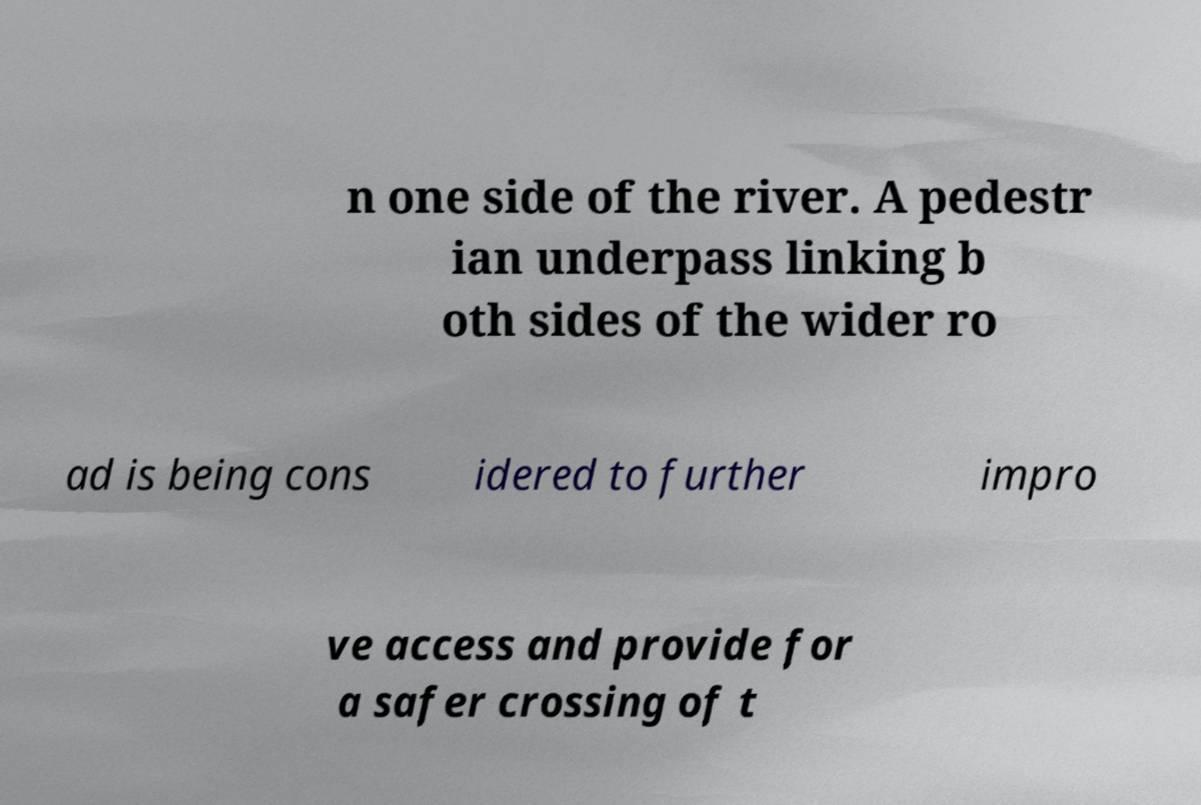I need the written content from this picture converted into text. Can you do that? n one side of the river. A pedestr ian underpass linking b oth sides of the wider ro ad is being cons idered to further impro ve access and provide for a safer crossing of t 